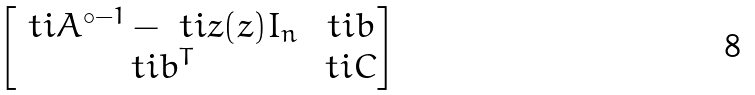Convert formula to latex. <formula><loc_0><loc_0><loc_500><loc_500>\begin{bmatrix} \ t i A ^ { \circ - 1 } - \ t i z ( z ) I _ { n } & \ t i b \\ \ t i b ^ { T } & \ t i C \end{bmatrix}</formula> 